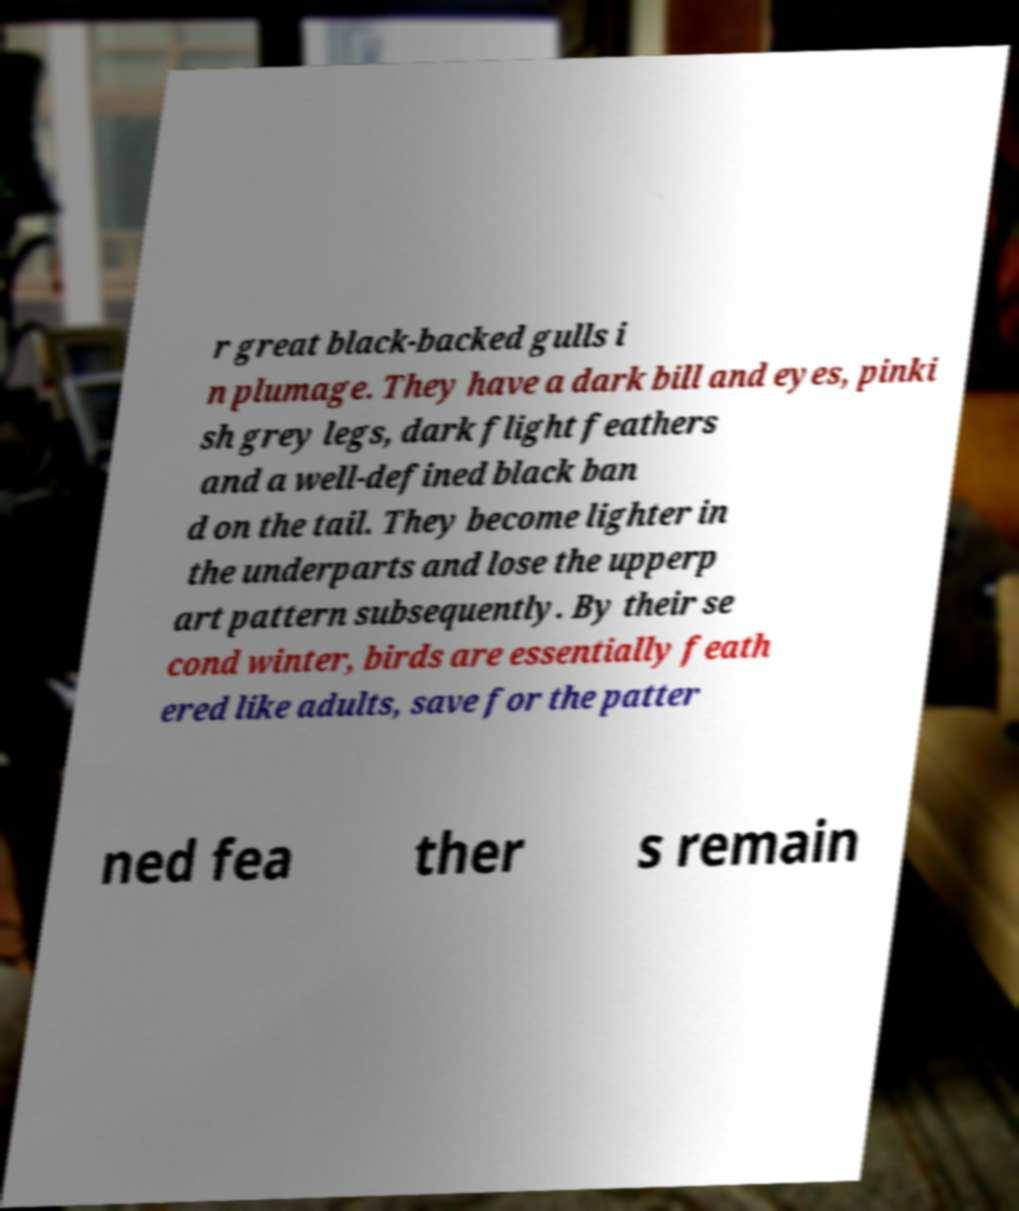I need the written content from this picture converted into text. Can you do that? r great black-backed gulls i n plumage. They have a dark bill and eyes, pinki sh grey legs, dark flight feathers and a well-defined black ban d on the tail. They become lighter in the underparts and lose the upperp art pattern subsequently. By their se cond winter, birds are essentially feath ered like adults, save for the patter ned fea ther s remain 